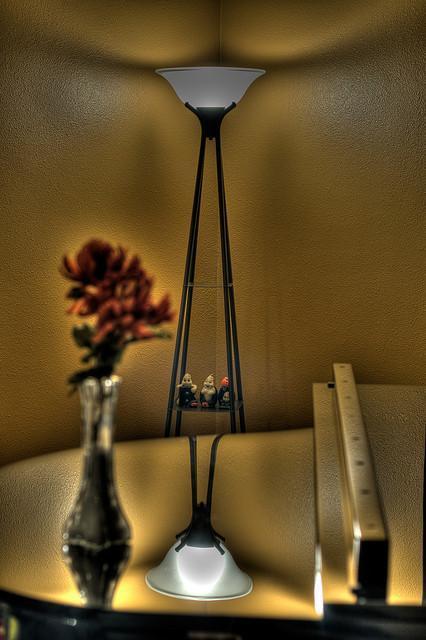How many vases can be seen?
Give a very brief answer. 1. 